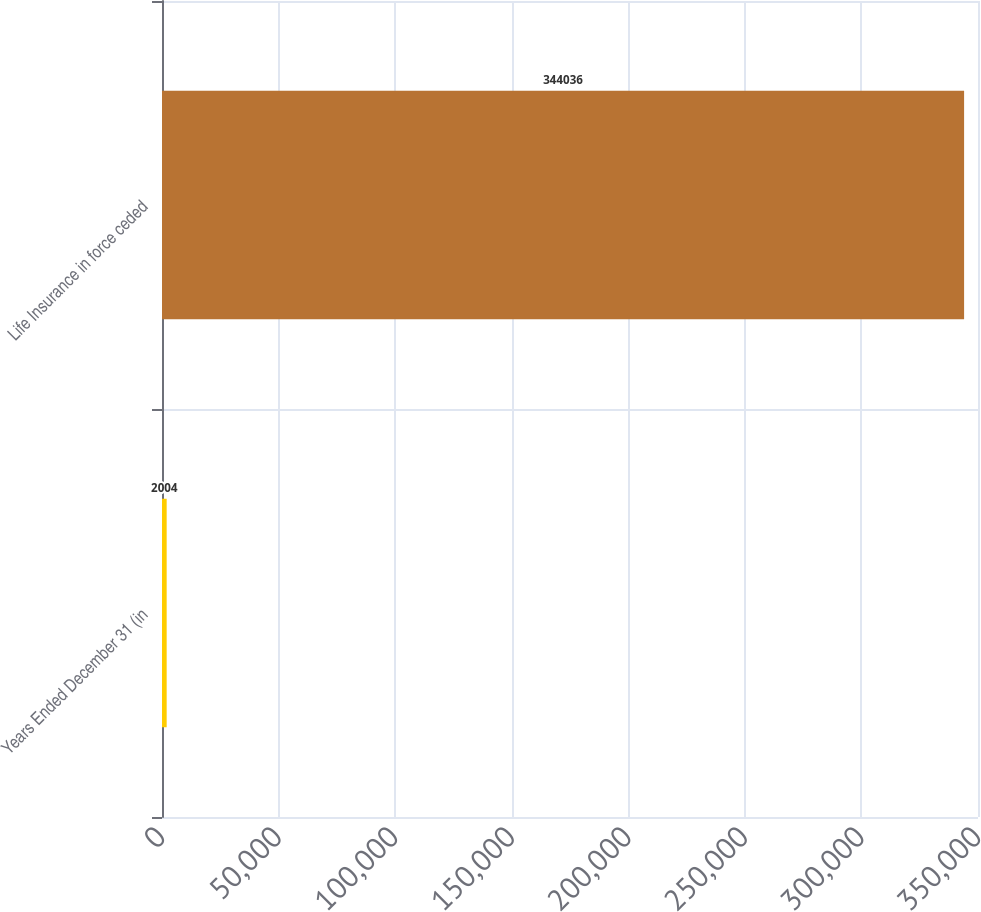Convert chart to OTSL. <chart><loc_0><loc_0><loc_500><loc_500><bar_chart><fcel>Years Ended December 31 (in<fcel>Life Insurance in force ceded<nl><fcel>2004<fcel>344036<nl></chart> 